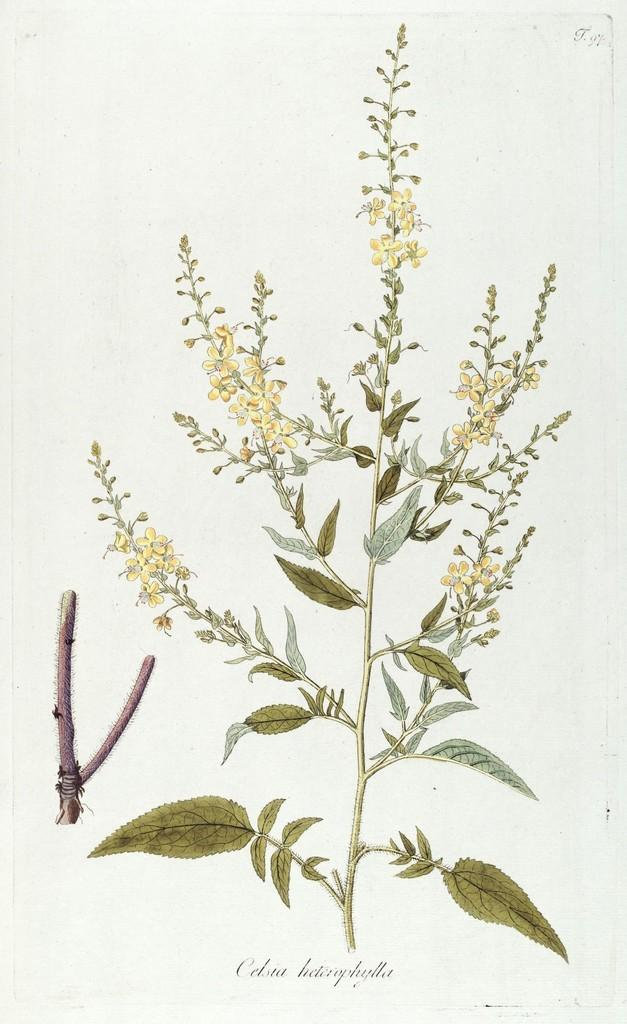What type of artwork is shown in the image? The image is a painting. What subject matter is depicted in the painting? The painting depicts a plant. What specific feature of the plant is highlighted in the painting? The plant has beautiful flowers. What type of dirt can be seen surrounding the plant in the painting? There is no dirt visible in the painting, as it is a painting of a plant with beautiful flowers. 